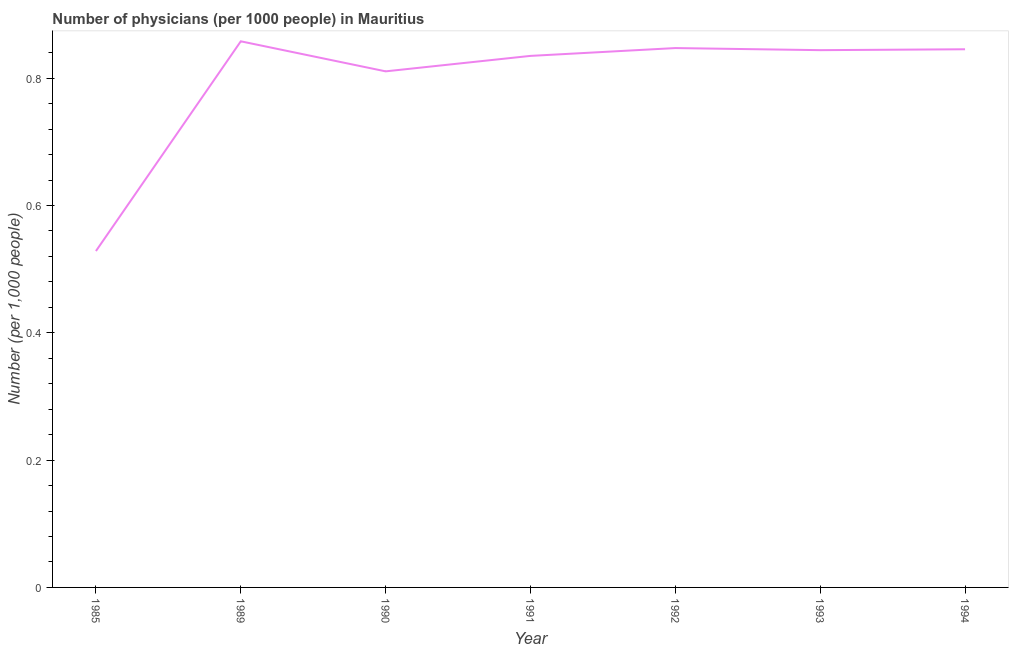What is the number of physicians in 1989?
Provide a short and direct response. 0.86. Across all years, what is the maximum number of physicians?
Your answer should be very brief. 0.86. Across all years, what is the minimum number of physicians?
Give a very brief answer. 0.53. In which year was the number of physicians maximum?
Your answer should be very brief. 1989. What is the sum of the number of physicians?
Provide a succinct answer. 5.57. What is the difference between the number of physicians in 1990 and 1992?
Keep it short and to the point. -0.04. What is the average number of physicians per year?
Make the answer very short. 0.8. What is the median number of physicians?
Offer a very short reply. 0.84. What is the ratio of the number of physicians in 1990 to that in 1993?
Give a very brief answer. 0.96. What is the difference between the highest and the second highest number of physicians?
Offer a very short reply. 0.01. Is the sum of the number of physicians in 1985 and 1992 greater than the maximum number of physicians across all years?
Provide a short and direct response. Yes. What is the difference between the highest and the lowest number of physicians?
Provide a succinct answer. 0.33. Does the number of physicians monotonically increase over the years?
Your answer should be compact. No. How many years are there in the graph?
Your answer should be very brief. 7. Are the values on the major ticks of Y-axis written in scientific E-notation?
Keep it short and to the point. No. Does the graph contain any zero values?
Your answer should be compact. No. What is the title of the graph?
Offer a terse response. Number of physicians (per 1000 people) in Mauritius. What is the label or title of the X-axis?
Provide a short and direct response. Year. What is the label or title of the Y-axis?
Your response must be concise. Number (per 1,0 people). What is the Number (per 1,000 people) in 1985?
Your answer should be compact. 0.53. What is the Number (per 1,000 people) of 1989?
Your answer should be compact. 0.86. What is the Number (per 1,000 people) in 1990?
Provide a short and direct response. 0.81. What is the Number (per 1,000 people) in 1991?
Give a very brief answer. 0.84. What is the Number (per 1,000 people) in 1992?
Give a very brief answer. 0.85. What is the Number (per 1,000 people) of 1993?
Offer a terse response. 0.84. What is the Number (per 1,000 people) of 1994?
Your answer should be compact. 0.85. What is the difference between the Number (per 1,000 people) in 1985 and 1989?
Provide a succinct answer. -0.33. What is the difference between the Number (per 1,000 people) in 1985 and 1990?
Your answer should be compact. -0.28. What is the difference between the Number (per 1,000 people) in 1985 and 1991?
Offer a terse response. -0.31. What is the difference between the Number (per 1,000 people) in 1985 and 1992?
Give a very brief answer. -0.32. What is the difference between the Number (per 1,000 people) in 1985 and 1993?
Provide a succinct answer. -0.32. What is the difference between the Number (per 1,000 people) in 1985 and 1994?
Make the answer very short. -0.32. What is the difference between the Number (per 1,000 people) in 1989 and 1990?
Ensure brevity in your answer.  0.05. What is the difference between the Number (per 1,000 people) in 1989 and 1991?
Your answer should be very brief. 0.02. What is the difference between the Number (per 1,000 people) in 1989 and 1992?
Offer a terse response. 0.01. What is the difference between the Number (per 1,000 people) in 1989 and 1993?
Your answer should be compact. 0.01. What is the difference between the Number (per 1,000 people) in 1989 and 1994?
Make the answer very short. 0.01. What is the difference between the Number (per 1,000 people) in 1990 and 1991?
Give a very brief answer. -0.02. What is the difference between the Number (per 1,000 people) in 1990 and 1992?
Your answer should be compact. -0.04. What is the difference between the Number (per 1,000 people) in 1990 and 1993?
Make the answer very short. -0.03. What is the difference between the Number (per 1,000 people) in 1990 and 1994?
Offer a terse response. -0.03. What is the difference between the Number (per 1,000 people) in 1991 and 1992?
Offer a terse response. -0.01. What is the difference between the Number (per 1,000 people) in 1991 and 1993?
Your response must be concise. -0.01. What is the difference between the Number (per 1,000 people) in 1991 and 1994?
Ensure brevity in your answer.  -0.01. What is the difference between the Number (per 1,000 people) in 1992 and 1993?
Keep it short and to the point. 0. What is the difference between the Number (per 1,000 people) in 1992 and 1994?
Your answer should be compact. 0. What is the difference between the Number (per 1,000 people) in 1993 and 1994?
Make the answer very short. -0. What is the ratio of the Number (per 1,000 people) in 1985 to that in 1989?
Give a very brief answer. 0.62. What is the ratio of the Number (per 1,000 people) in 1985 to that in 1990?
Provide a short and direct response. 0.65. What is the ratio of the Number (per 1,000 people) in 1985 to that in 1991?
Make the answer very short. 0.63. What is the ratio of the Number (per 1,000 people) in 1985 to that in 1992?
Make the answer very short. 0.62. What is the ratio of the Number (per 1,000 people) in 1985 to that in 1993?
Provide a succinct answer. 0.63. What is the ratio of the Number (per 1,000 people) in 1989 to that in 1990?
Your response must be concise. 1.06. What is the ratio of the Number (per 1,000 people) in 1989 to that in 1992?
Make the answer very short. 1.01. What is the ratio of the Number (per 1,000 people) in 1989 to that in 1993?
Keep it short and to the point. 1.02. What is the ratio of the Number (per 1,000 people) in 1990 to that in 1991?
Provide a succinct answer. 0.97. What is the ratio of the Number (per 1,000 people) in 1990 to that in 1993?
Make the answer very short. 0.96. What is the ratio of the Number (per 1,000 people) in 1992 to that in 1993?
Offer a very short reply. 1. 